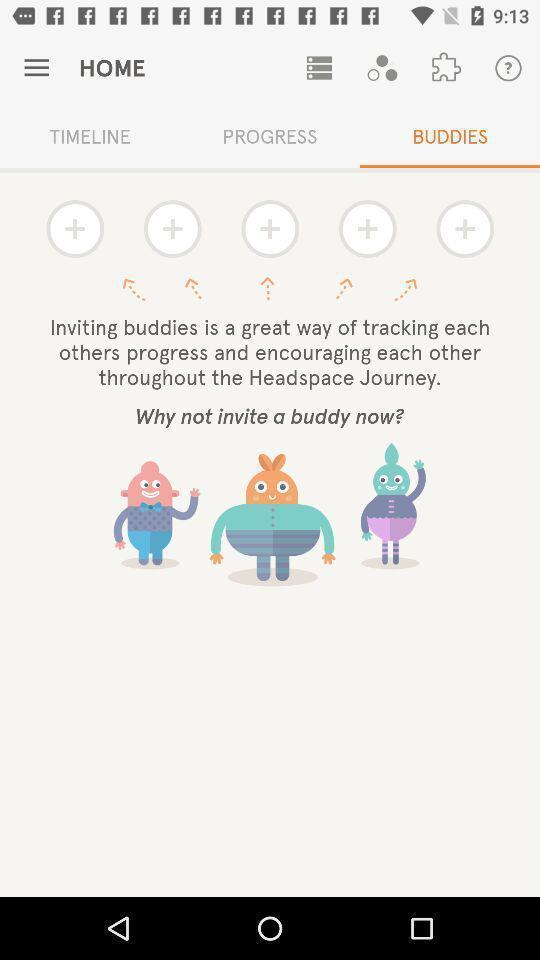Provide a textual representation of this image. Page to invite buddies. 